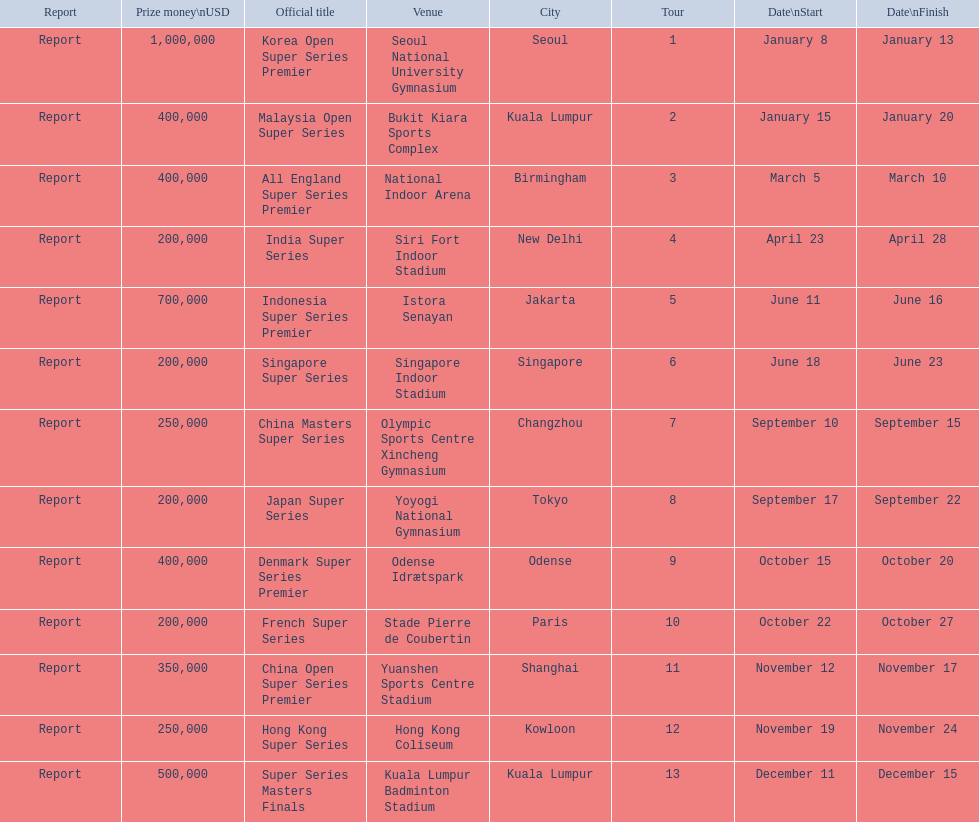What are all the titles? Korea Open Super Series Premier, Malaysia Open Super Series, All England Super Series Premier, India Super Series, Indonesia Super Series Premier, Singapore Super Series, China Masters Super Series, Japan Super Series, Denmark Super Series Premier, French Super Series, China Open Super Series Premier, Hong Kong Super Series, Super Series Masters Finals. When did they take place? January 8, January 15, March 5, April 23, June 11, June 18, September 10, September 17, October 15, October 22, November 12, November 19, December 11. Which title took place in december? Super Series Masters Finals. 